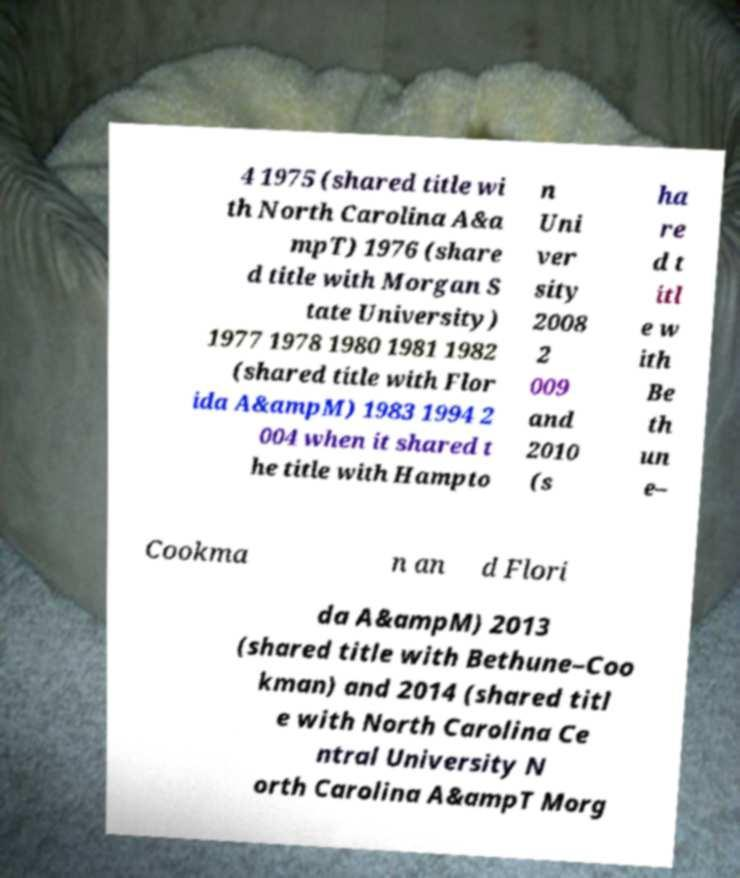Could you assist in decoding the text presented in this image and type it out clearly? 4 1975 (shared title wi th North Carolina A&a mpT) 1976 (share d title with Morgan S tate University) 1977 1978 1980 1981 1982 (shared title with Flor ida A&ampM) 1983 1994 2 004 when it shared t he title with Hampto n Uni ver sity 2008 2 009 and 2010 (s ha re d t itl e w ith Be th un e– Cookma n an d Flori da A&ampM) 2013 (shared title with Bethune–Coo kman) and 2014 (shared titl e with North Carolina Ce ntral University N orth Carolina A&ampT Morg 